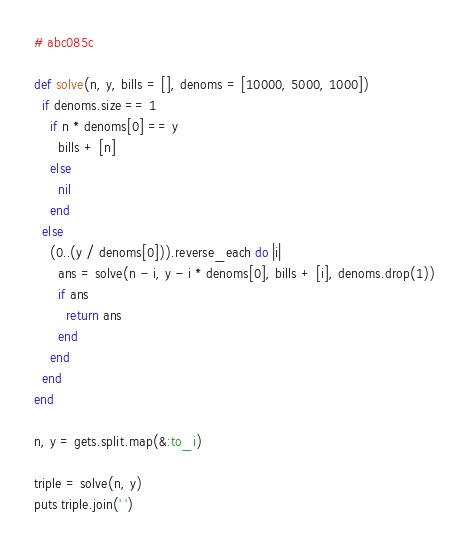Convert code to text. <code><loc_0><loc_0><loc_500><loc_500><_Ruby_># abc085c

def solve(n, y, bills = [], denoms = [10000, 5000, 1000])
  if denoms.size == 1
    if n * denoms[0] == y
      bills + [n]
    else
      nil
    end
  else
    (0..(y / denoms[0])).reverse_each do |i|
      ans = solve(n - i, y - i * denoms[0], bills + [i], denoms.drop(1))
      if ans
        return ans
      end
    end
  end
end

n, y = gets.split.map(&:to_i)

triple = solve(n, y)
puts triple.join(' ')
</code> 